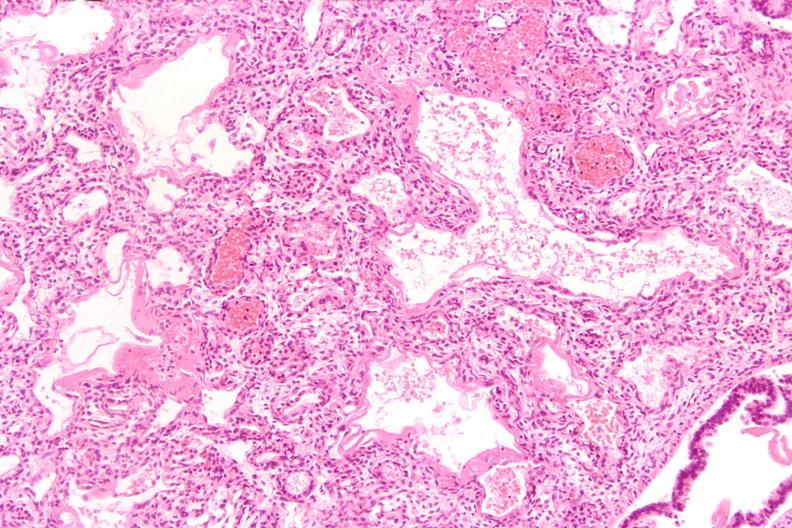what is present?
Answer the question using a single word or phrase. Respiratory 